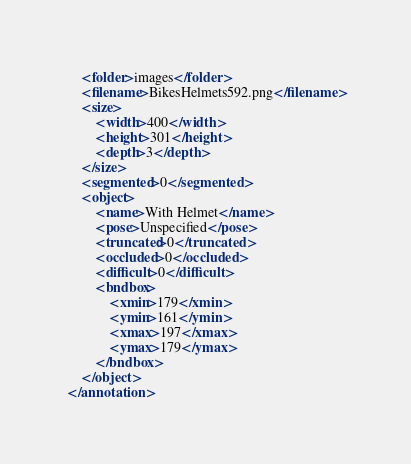<code> <loc_0><loc_0><loc_500><loc_500><_XML_>    <folder>images</folder>
    <filename>BikesHelmets592.png</filename>
    <size>
        <width>400</width>
        <height>301</height>
        <depth>3</depth>
    </size>
    <segmented>0</segmented>
    <object>
        <name>With Helmet</name>
        <pose>Unspecified</pose>
        <truncated>0</truncated>
        <occluded>0</occluded>
        <difficult>0</difficult>
        <bndbox>
            <xmin>179</xmin>
            <ymin>161</ymin>
            <xmax>197</xmax>
            <ymax>179</ymax>
        </bndbox>
    </object>
</annotation></code> 